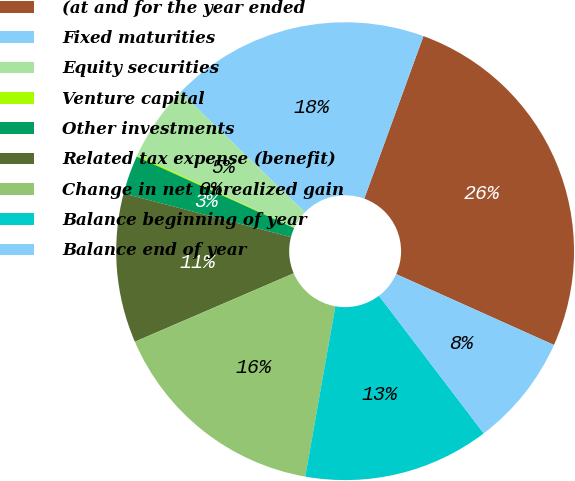Convert chart to OTSL. <chart><loc_0><loc_0><loc_500><loc_500><pie_chart><fcel>(at and for the year ended<fcel>Fixed maturities<fcel>Equity securities<fcel>Venture capital<fcel>Other investments<fcel>Related tax expense (benefit)<fcel>Change in net unrealized gain<fcel>Balance beginning of year<fcel>Balance end of year<nl><fcel>26.16%<fcel>18.34%<fcel>5.32%<fcel>0.12%<fcel>2.72%<fcel>10.53%<fcel>15.74%<fcel>13.14%<fcel>7.93%<nl></chart> 